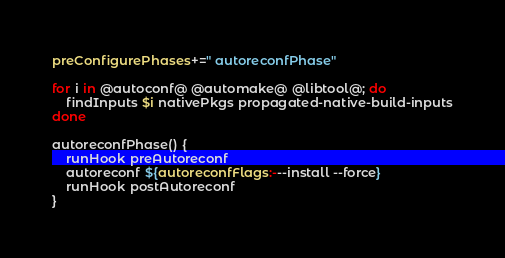<code> <loc_0><loc_0><loc_500><loc_500><_Bash_>preConfigurePhases+=" autoreconfPhase"

for i in @autoconf@ @automake@ @libtool@; do
    findInputs $i nativePkgs propagated-native-build-inputs
done

autoreconfPhase() {
    runHook preAutoreconf
    autoreconf ${autoreconfFlags:---install --force}
    runHook postAutoreconf
}
</code> 